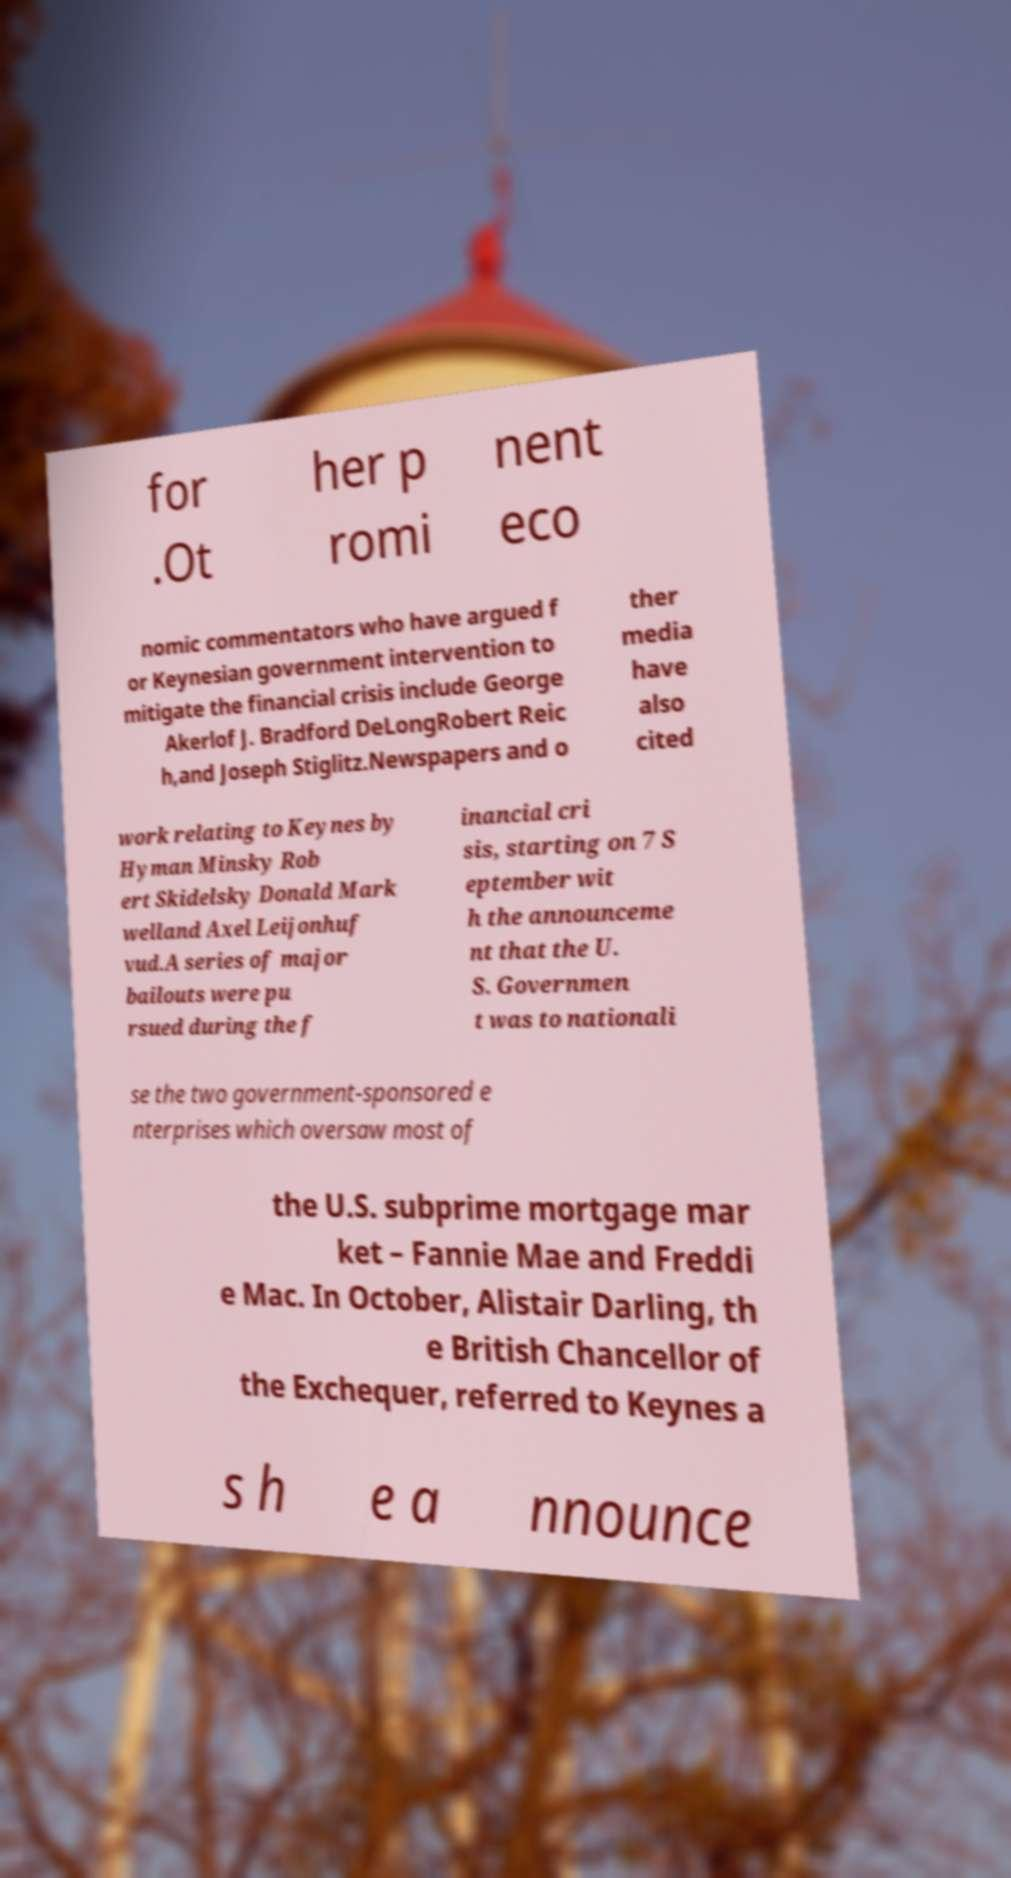Please read and relay the text visible in this image. What does it say? for .Ot her p romi nent eco nomic commentators who have argued f or Keynesian government intervention to mitigate the financial crisis include George Akerlof J. Bradford DeLongRobert Reic h,and Joseph Stiglitz.Newspapers and o ther media have also cited work relating to Keynes by Hyman Minsky Rob ert Skidelsky Donald Mark welland Axel Leijonhuf vud.A series of major bailouts were pu rsued during the f inancial cri sis, starting on 7 S eptember wit h the announceme nt that the U. S. Governmen t was to nationali se the two government-sponsored e nterprises which oversaw most of the U.S. subprime mortgage mar ket – Fannie Mae and Freddi e Mac. In October, Alistair Darling, th e British Chancellor of the Exchequer, referred to Keynes a s h e a nnounce 